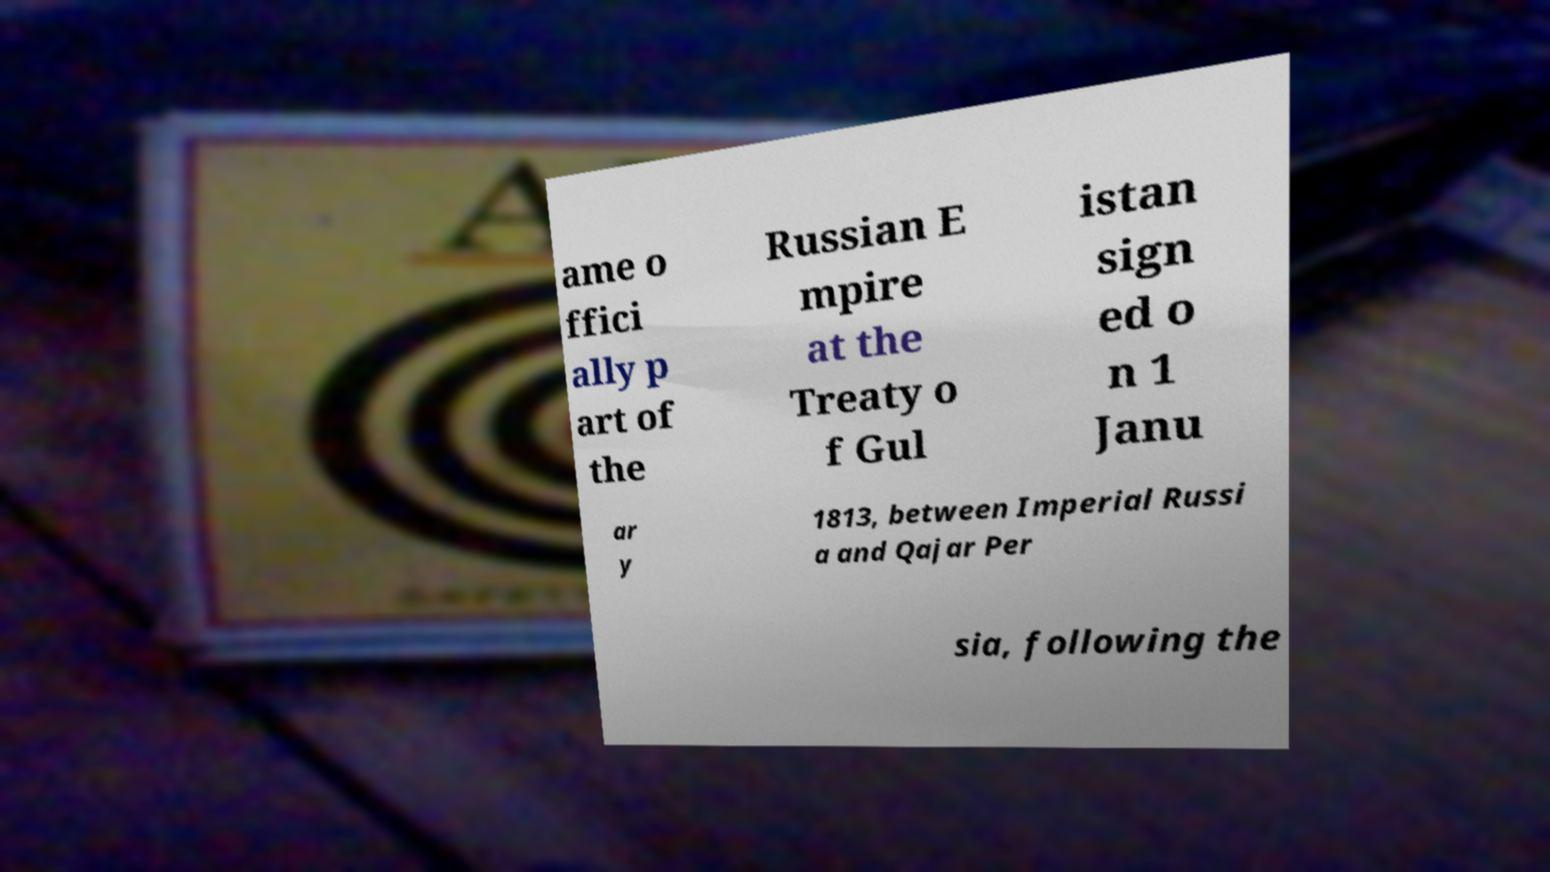Please identify and transcribe the text found in this image. ame o ffici ally p art of the Russian E mpire at the Treaty o f Gul istan sign ed o n 1 Janu ar y 1813, between Imperial Russi a and Qajar Per sia, following the 